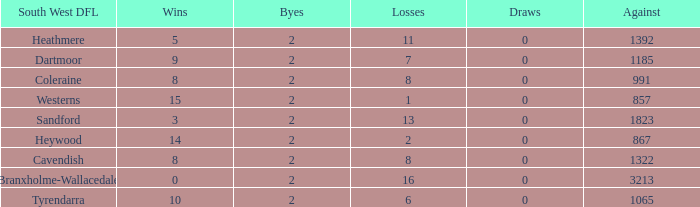Which draws have an average of 14 wins? 0.0. 